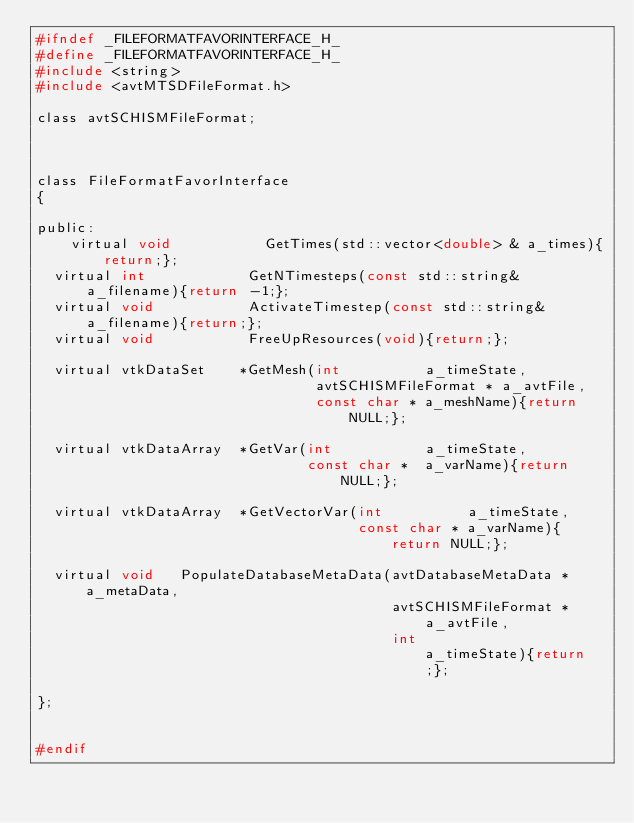Convert code to text. <code><loc_0><loc_0><loc_500><loc_500><_C_>#ifndef _FILEFORMATFAVORINTERFACE_H_
#define _FILEFORMATFAVORINTERFACE_H_  
#include <string>
#include <avtMTSDFileFormat.h>

class avtSCHISMFileFormat;



class FileFormatFavorInterface
{

public:
	virtual void           GetTimes(std::vector<double> & a_times){return;};
  virtual int            GetNTimesteps(const std::string& a_filename){return -1;};
  virtual void           ActivateTimestep(const std::string& a_filename){return;};
  virtual void           FreeUpResources(void){return;}; 
  
  virtual vtkDataSet    *GetMesh(int          a_timeState, 
	                             avtSCHISMFileFormat * a_avtFile,
								 const char * a_meshName){return NULL;};

  virtual vtkDataArray  *GetVar(int           a_timeState,
                                const char *  a_varName){return NULL;};

  virtual vtkDataArray  *GetVectorVar(int          a_timeState, 
                                      const char * a_varName){return NULL;};

  virtual void   PopulateDatabaseMetaData(avtDatabaseMetaData * a_metaData, 
	                                      avtSCHISMFileFormat * a_avtFile,
										  int                   a_timeState){return;};
 
};


#endif</code> 